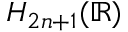<formula> <loc_0><loc_0><loc_500><loc_500>H _ { 2 n + 1 } ( \mathbb { R } )</formula> 